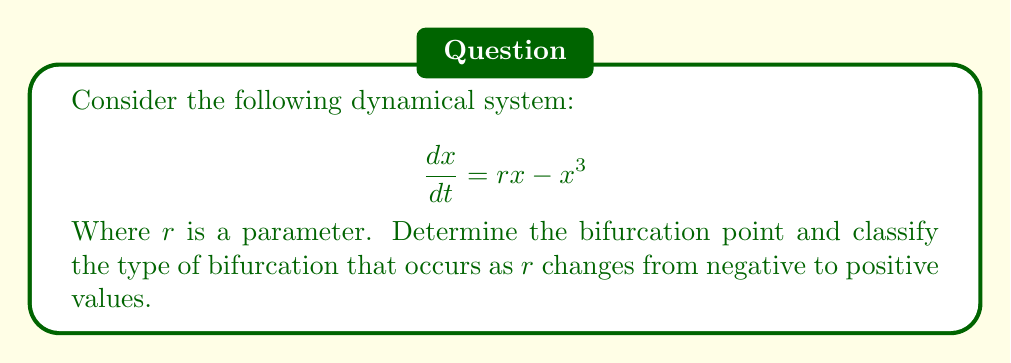What is the answer to this math problem? 1. First, find the equilibrium points by setting $\frac{dx}{dt} = 0$:
   $$r x - x^3 = 0$$
   $$x(r - x^2) = 0$$
   
   This gives us $x = 0$ and $x = \pm\sqrt{r}$ (when $r > 0$).

2. Analyze the stability of these equilibrium points:
   - For $x = 0$:
     $$\frac{d}{dx}(rx - x^3)|_{x=0} = r$$
     Stable when $r < 0$, unstable when $r > 0$

   - For $x = \pm\sqrt{r}$ (when $r > 0$):
     $$\frac{d}{dx}(rx - x^3)|_{x=\pm\sqrt{r}} = r - 3(\pm\sqrt{r})^2 = r - 3r = -2r < 0$$
     These points are stable when they exist ($r > 0$)

3. Observe the behavior:
   - When $r < 0$, there is one stable equilibrium at $x = 0$
   - When $r = 0$, there is one non-hyperbolic equilibrium at $x = 0$
   - When $r > 0$, $x = 0$ becomes unstable, and two new stable equilibria appear at $x = \pm\sqrt{r}$

4. Conclusion:
   The bifurcation occurs at $r = 0$. As $r$ increases through 0, the single stable equilibrium splits into two stable equilibria, while the original equilibrium becomes unstable. This behavior is characteristic of a pitchfork bifurcation.
Answer: Pitchfork bifurcation at $r = 0$ 